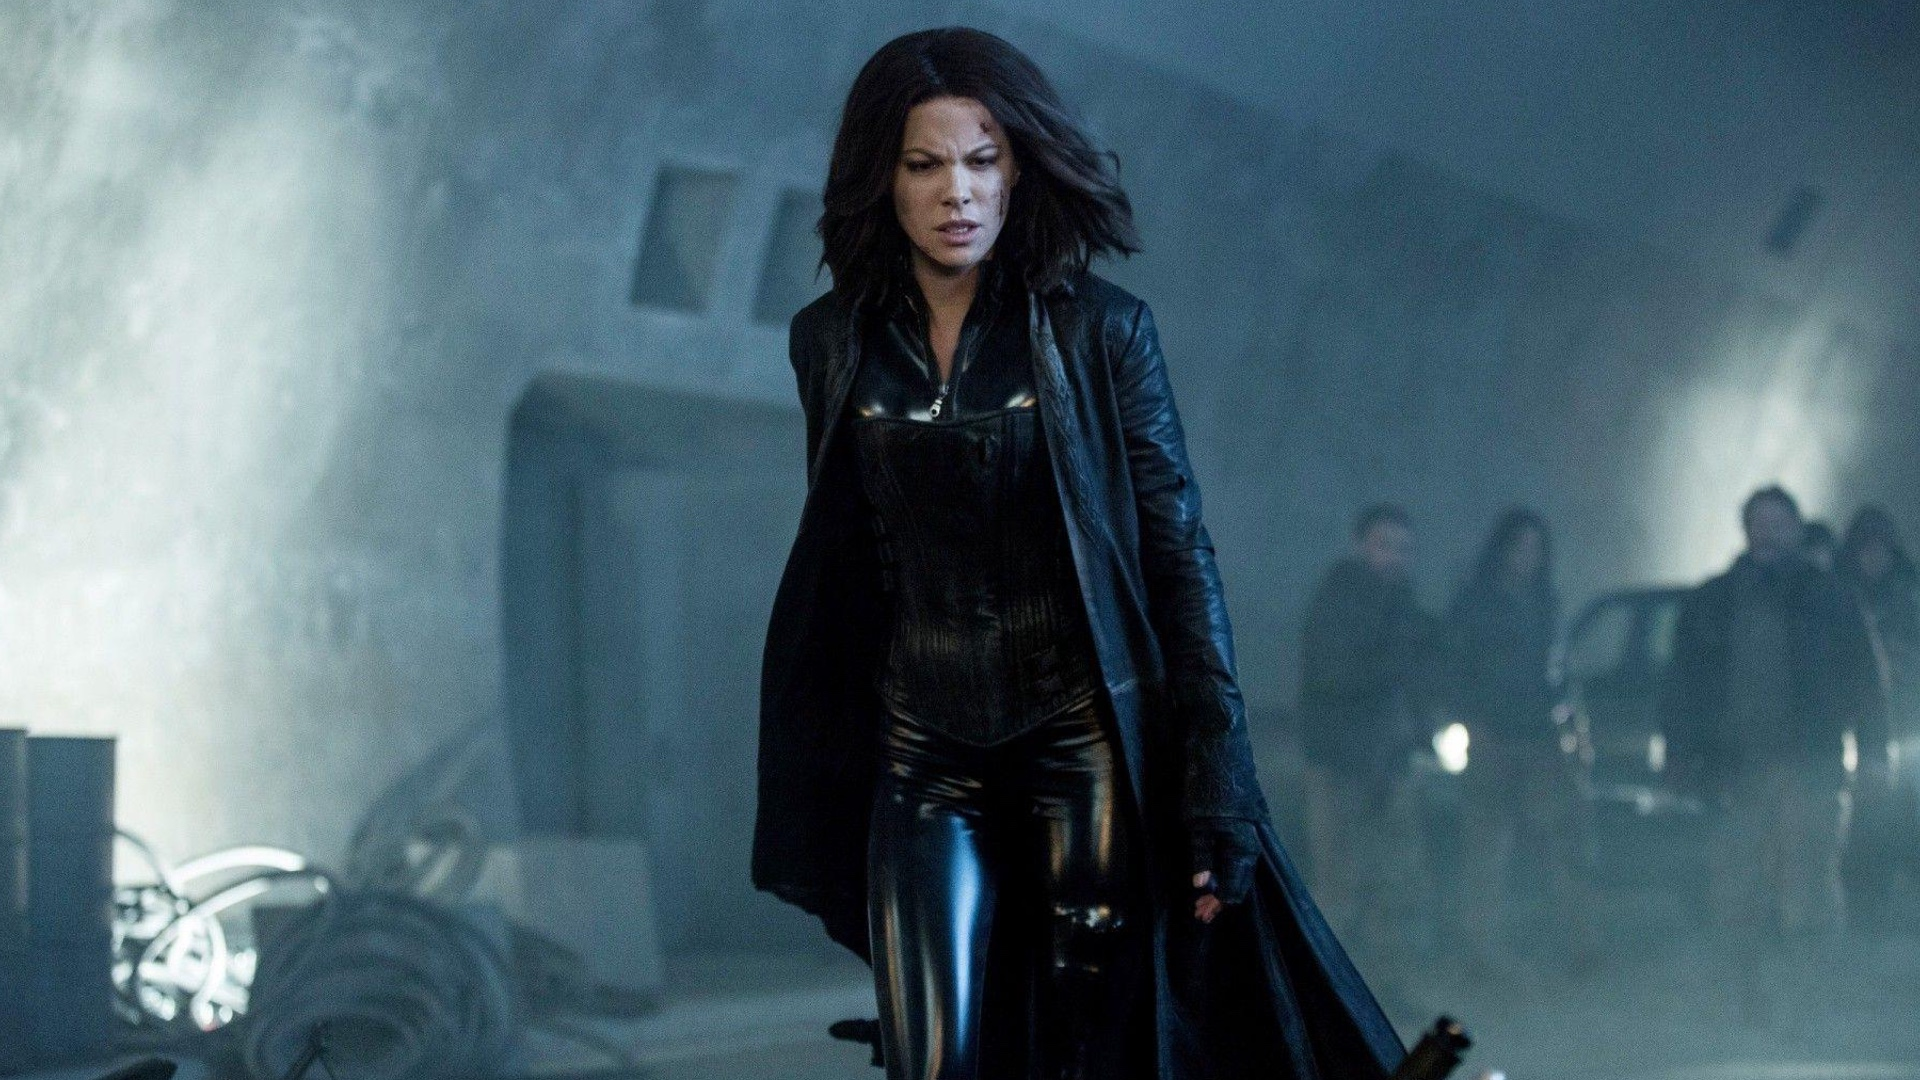Can you describe in detail a possible plot for the next Underworld movie, based on this image? In the next Underworld movie, titled 'Underworld: Bloodlines', the story dives into Selene's quest to uncover the origins of the ancient war between vampires and lycans. The image represents a pivotal moment where Selene discovers a hidden industrial facility that holds the key to her past and the secrets of the vampire lineage. Here, she faces formidable new enemies and encounters Viktor, who has returned from exile to protect these secrets. As Selene navigates through the fog, she uncovers a clandestine experiment aiming to create a vampire-lycan hybrid with unprecedented power. Alongside trusted allies and unexpected new friends, Selene must prevent this hybrid from being unleashed, which threatens to tip the balance of the eternal war. The movie combines intense action sequences, deep lore exploration, and emotional character arcs, culminating in a showdown that will determine the fate of both species. 